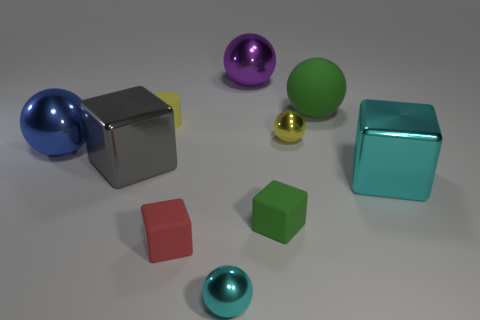There is a tiny thing that is the same color as the tiny matte cylinder; what material is it?
Keep it short and to the point. Metal. What number of things are either tiny rubber cubes or objects that are right of the small red object?
Your response must be concise. 7. How many tiny blue matte balls are there?
Keep it short and to the point. 0. Are there any green rubber things that have the same size as the rubber cylinder?
Provide a short and direct response. Yes. Are there fewer green matte things that are behind the gray object than red matte objects?
Offer a terse response. No. Do the yellow ball and the cyan ball have the same size?
Your answer should be very brief. Yes. There is a sphere that is made of the same material as the cylinder; what is its size?
Give a very brief answer. Large. How many tiny cubes have the same color as the matte sphere?
Your response must be concise. 1. Are there fewer cylinders that are right of the green cube than shiny spheres that are right of the red matte thing?
Offer a very short reply. Yes. There is a green object right of the green matte cube; does it have the same shape as the large purple object?
Your answer should be very brief. Yes. 